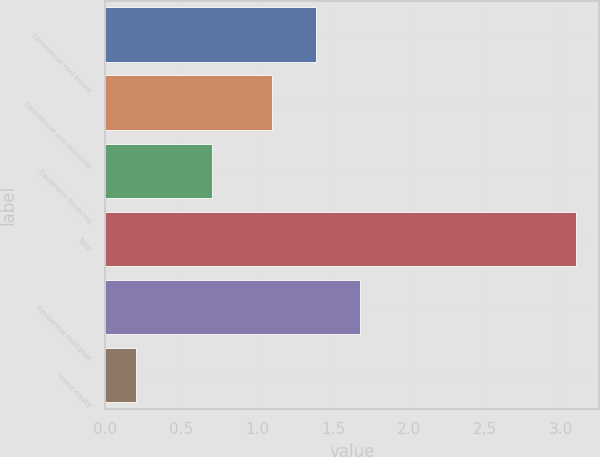<chart> <loc_0><loc_0><loc_500><loc_500><bar_chart><fcel>Commercial real estate<fcel>Commercial and industrial<fcel>Equipment financing<fcel>Total<fcel>Residential mortgage<fcel>Home equity<nl><fcel>1.39<fcel>1.1<fcel>0.7<fcel>3.1<fcel>1.68<fcel>0.2<nl></chart> 